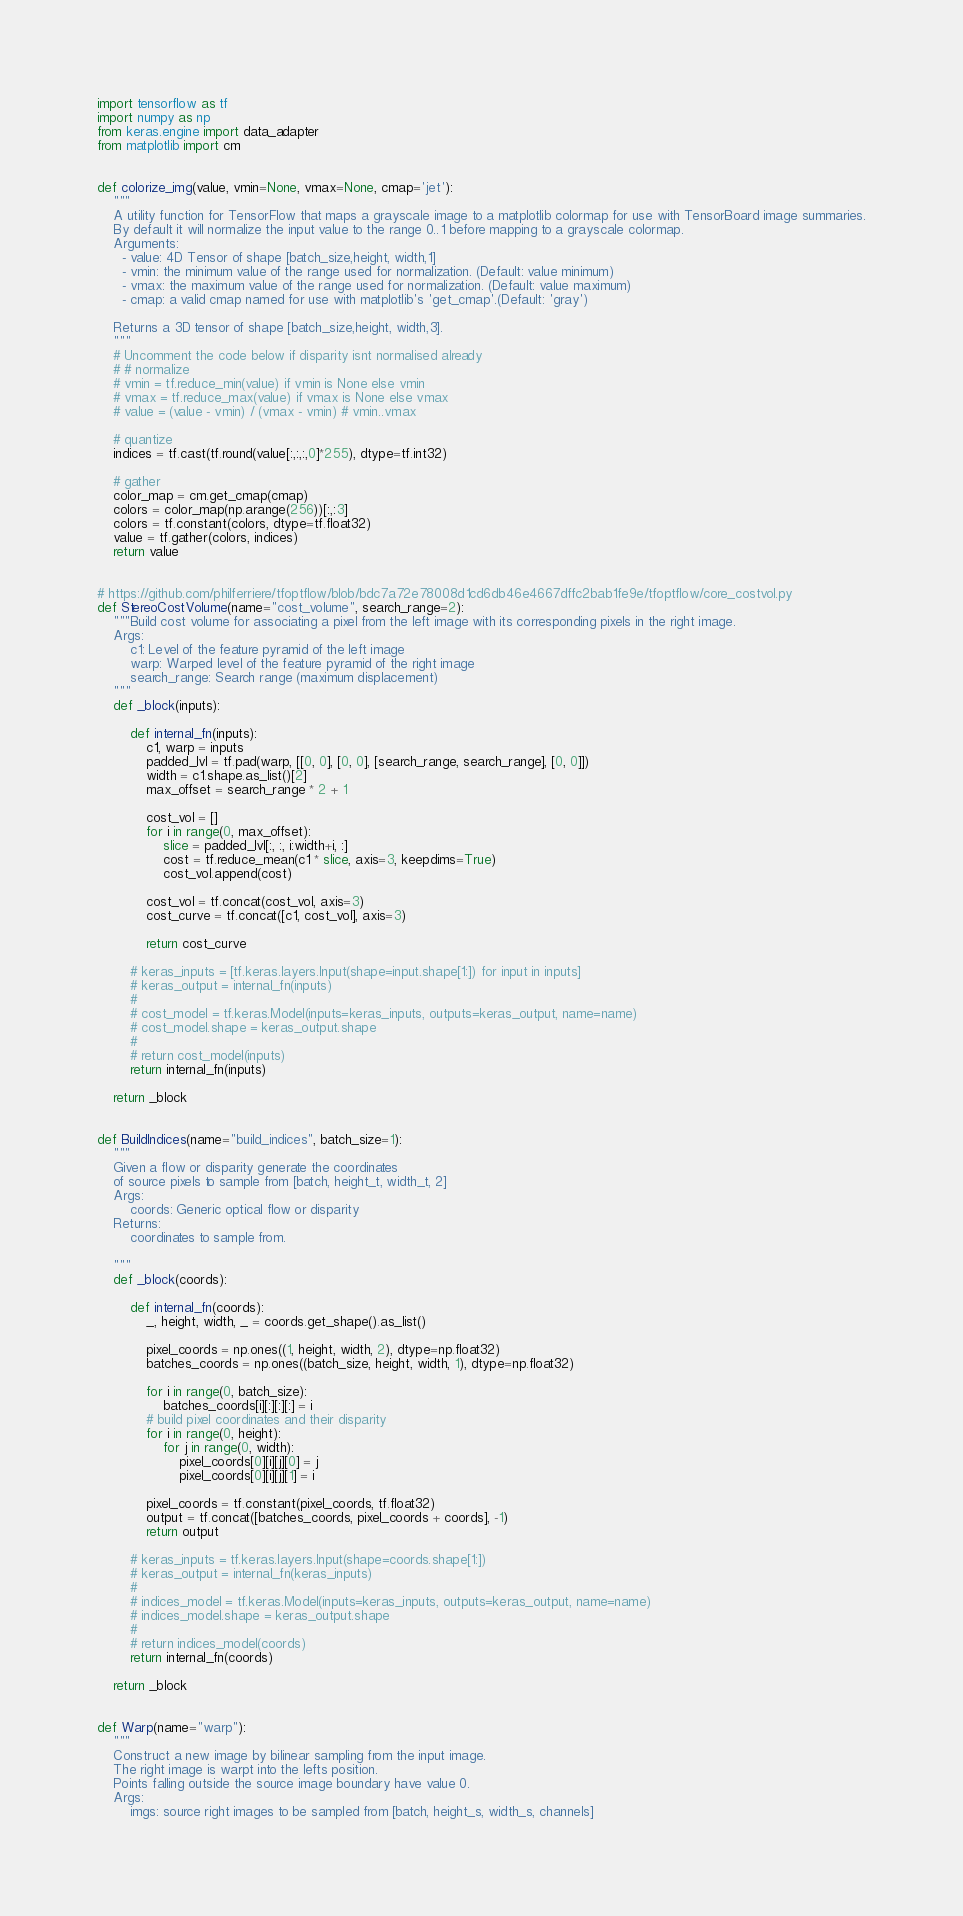Convert code to text. <code><loc_0><loc_0><loc_500><loc_500><_Python_>import tensorflow as tf
import numpy as np
from keras.engine import data_adapter
from matplotlib import cm


def colorize_img(value, vmin=None, vmax=None, cmap='jet'):
    """
    A utility function for TensorFlow that maps a grayscale image to a matplotlib colormap for use with TensorBoard image summaries.
    By default it will normalize the input value to the range 0..1 before mapping to a grayscale colormap.
    Arguments:
      - value: 4D Tensor of shape [batch_size,height, width,1]
      - vmin: the minimum value of the range used for normalization. (Default: value minimum)
      - vmax: the maximum value of the range used for normalization. (Default: value maximum)
      - cmap: a valid cmap named for use with matplotlib's 'get_cmap'.(Default: 'gray')
    
    Returns a 3D tensor of shape [batch_size,height, width,3].
    """
    # Uncomment the code below if disparity isnt normalised already
    # # normalize
    # vmin = tf.reduce_min(value) if vmin is None else vmin
    # vmax = tf.reduce_max(value) if vmax is None else vmax
    # value = (value - vmin) / (vmax - vmin) # vmin..vmax

    # quantize
    indices = tf.cast(tf.round(value[:,:,:,0]*255), dtype=tf.int32)

    # gather
    color_map = cm.get_cmap(cmap)
    colors = color_map(np.arange(256))[:,:3]
    colors = tf.constant(colors, dtype=tf.float32)
    value = tf.gather(colors, indices)
    return value


# https://github.com/philferriere/tfoptflow/blob/bdc7a72e78008d1cd6db46e4667dffc2bab1fe9e/tfoptflow/core_costvol.py
def StereoCostVolume(name="cost_volume", search_range=2):
    """Build cost volume for associating a pixel from the left image with its corresponding pixels in the right image.
    Args:
        c1: Level of the feature pyramid of the left image
        warp: Warped level of the feature pyramid of the right image
        search_range: Search range (maximum displacement)
    """
    def _block(inputs):

        def internal_fn(inputs):
            c1, warp = inputs
            padded_lvl = tf.pad(warp, [[0, 0], [0, 0], [search_range, search_range], [0, 0]])
            width = c1.shape.as_list()[2]
            max_offset = search_range * 2 + 1

            cost_vol = []
            for i in range(0, max_offset):
                slice = padded_lvl[:, :, i:width+i, :]
                cost = tf.reduce_mean(c1 * slice, axis=3, keepdims=True)
                cost_vol.append(cost)

            cost_vol = tf.concat(cost_vol, axis=3)
            cost_curve = tf.concat([c1, cost_vol], axis=3)

            return cost_curve

        # keras_inputs = [tf.keras.layers.Input(shape=input.shape[1:]) for input in inputs]
        # keras_output = internal_fn(inputs)
        #
        # cost_model = tf.keras.Model(inputs=keras_inputs, outputs=keras_output, name=name)
        # cost_model.shape = keras_output.shape
        #
        # return cost_model(inputs)
        return internal_fn(inputs)

    return _block


def BuildIndices(name="build_indices", batch_size=1):
    """
    Given a flow or disparity generate the coordinates
    of source pixels to sample from [batch, height_t, width_t, 2]
    Args:
        coords: Generic optical flow or disparity
    Returns:
        coordinates to sample from.

    """
    def _block(coords):

        def internal_fn(coords):
            _, height, width, _ = coords.get_shape().as_list()

            pixel_coords = np.ones((1, height, width, 2), dtype=np.float32)
            batches_coords = np.ones((batch_size, height, width, 1), dtype=np.float32)

            for i in range(0, batch_size):
                batches_coords[i][:][:][:] = i
            # build pixel coordinates and their disparity
            for i in range(0, height):
                for j in range(0, width):
                    pixel_coords[0][i][j][0] = j
                    pixel_coords[0][i][j][1] = i

            pixel_coords = tf.constant(pixel_coords, tf.float32)
            output = tf.concat([batches_coords, pixel_coords + coords], -1)
            return output

        # keras_inputs = tf.keras.layers.Input(shape=coords.shape[1:])
        # keras_output = internal_fn(keras_inputs)
        #
        # indices_model = tf.keras.Model(inputs=keras_inputs, outputs=keras_output, name=name)
        # indices_model.shape = keras_output.shape
        #
        # return indices_model(coords)
        return internal_fn(coords)

    return _block


def Warp(name="warp"):
    """
    Construct a new image by bilinear sampling from the input image.
    The right image is warpt into the lefts position.
    Points falling outside the source image boundary have value 0.
    Args:
        imgs: source right images to be sampled from [batch, height_s, width_s, channels]</code> 